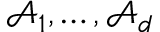<formula> <loc_0><loc_0><loc_500><loc_500>\mathcal { A } _ { 1 } , \dots , \mathcal { A } _ { d }</formula> 